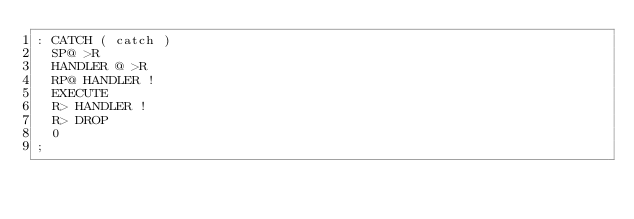<code> <loc_0><loc_0><loc_500><loc_500><_Forth_>: CATCH ( catch )
	SP@ >R
	HANDLER @ >R
	RP@ HANDLER !
	EXECUTE
	R> HANDLER !
	R> DROP
	0
;
</code> 